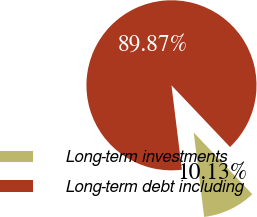<chart> <loc_0><loc_0><loc_500><loc_500><pie_chart><fcel>Long-term investments<fcel>Long-term debt including<nl><fcel>10.13%<fcel>89.87%<nl></chart> 